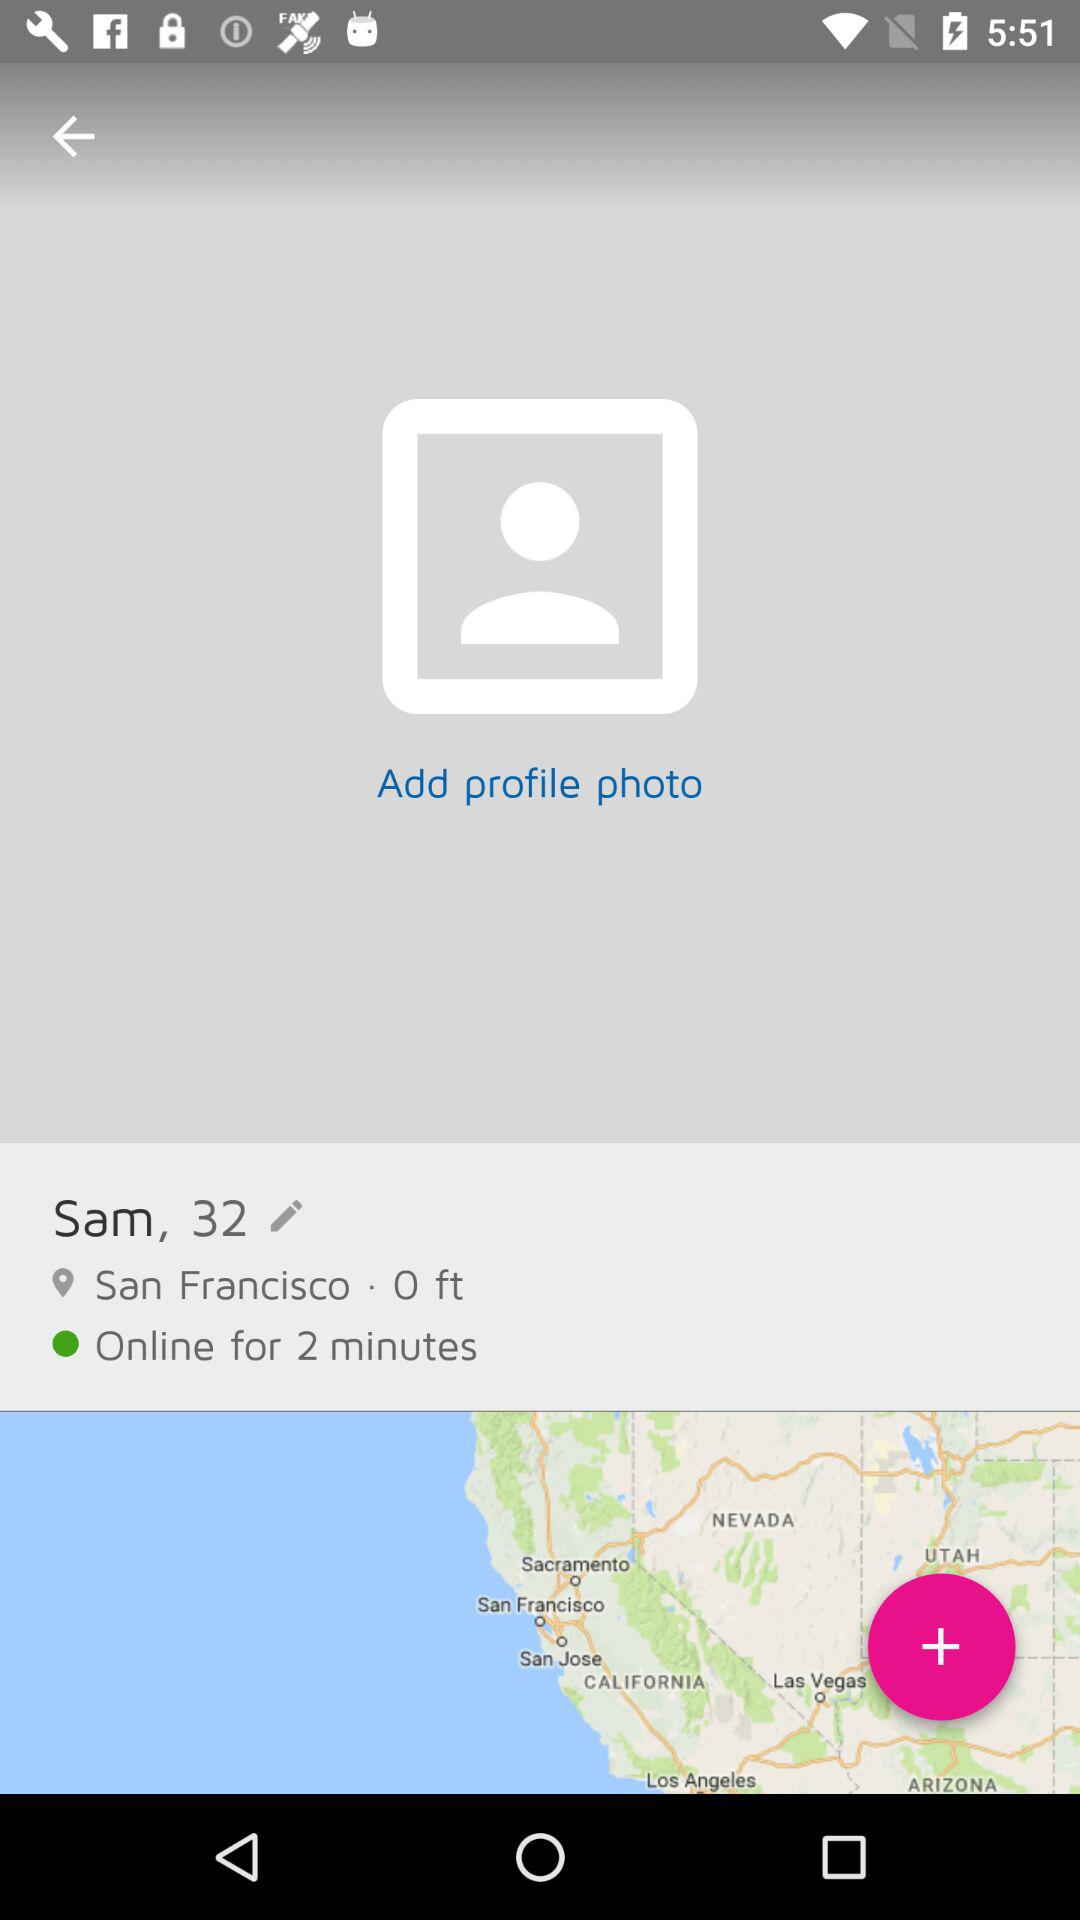What is the given location? The given location is San Francisco. 